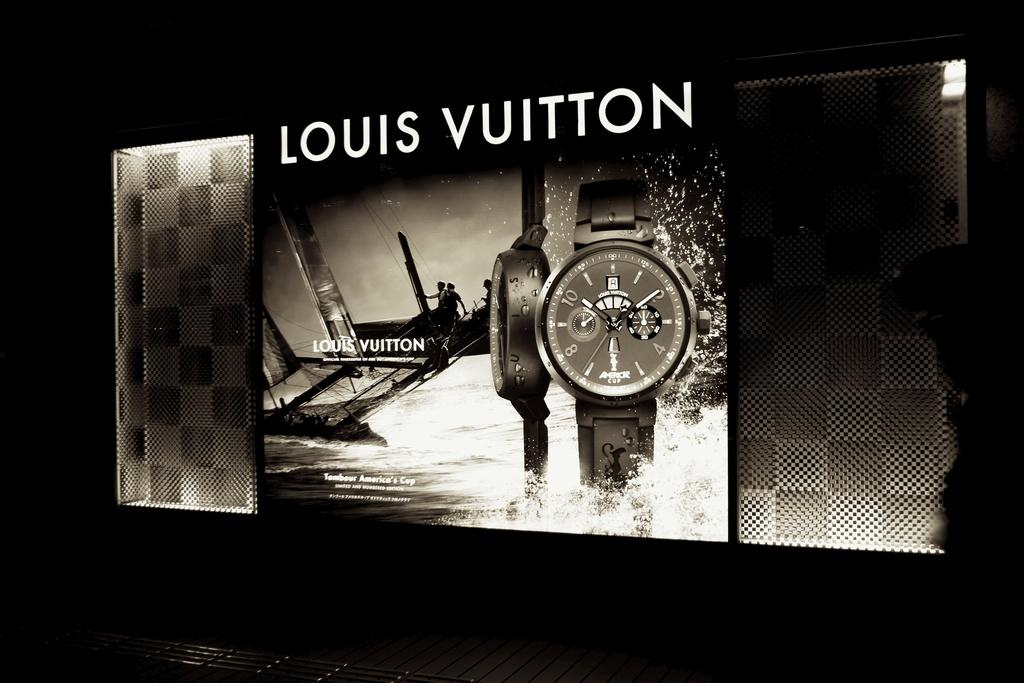Provide a one-sentence caption for the provided image. A black and white ad of a Vuitton watch. 